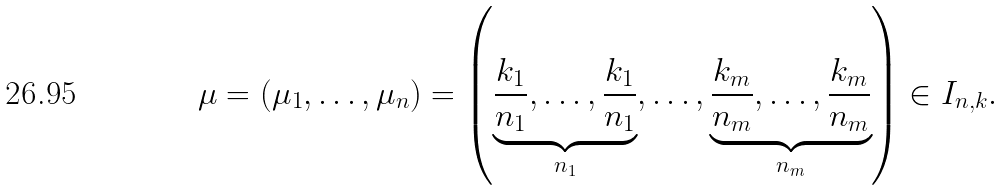Convert formula to latex. <formula><loc_0><loc_0><loc_500><loc_500>\mu = ( \mu _ { 1 } , \dots , \mu _ { n } ) = \left ( \underbrace { \frac { k _ { 1 } } { n _ { 1 } } , \dots , \frac { k _ { 1 } } { n _ { 1 } } } _ { n _ { 1 } } , \dots , \underbrace { \frac { k _ { m } } { n _ { m } } , \dots , \frac { k _ { m } } { n _ { m } } } _ { n _ { m } } \right ) \in I _ { n , k } .</formula> 